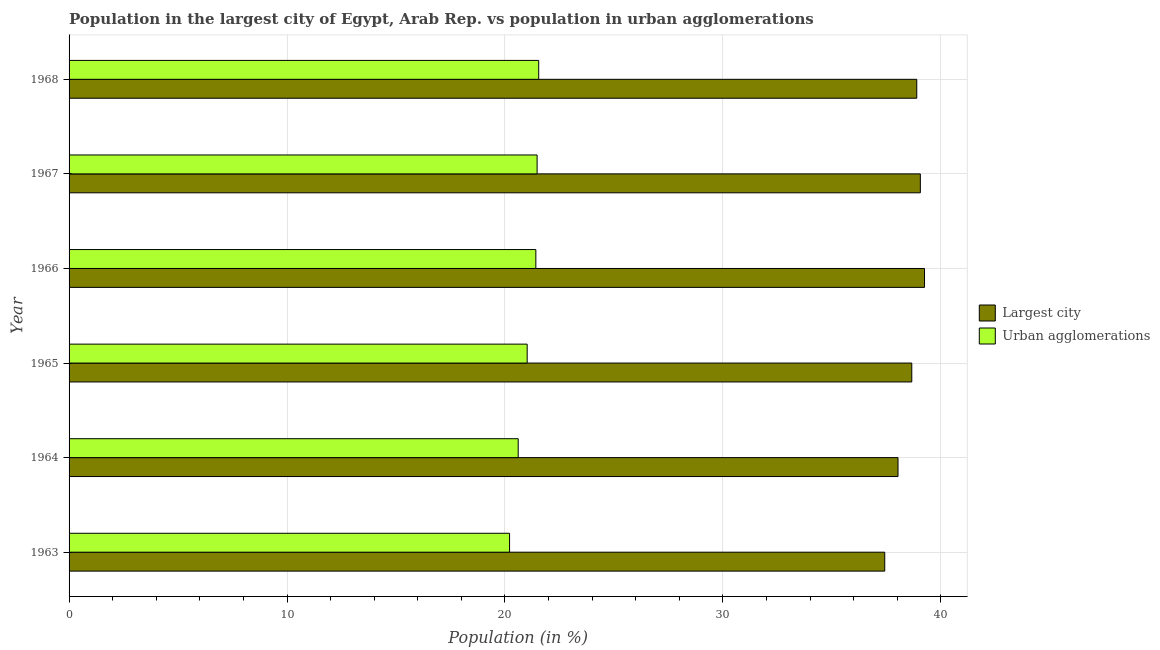How many groups of bars are there?
Your answer should be compact. 6. How many bars are there on the 4th tick from the bottom?
Offer a very short reply. 2. What is the label of the 3rd group of bars from the top?
Keep it short and to the point. 1966. What is the population in urban agglomerations in 1963?
Provide a short and direct response. 20.21. Across all years, what is the maximum population in urban agglomerations?
Your response must be concise. 21.55. Across all years, what is the minimum population in urban agglomerations?
Ensure brevity in your answer.  20.21. In which year was the population in the largest city maximum?
Your answer should be very brief. 1966. What is the total population in the largest city in the graph?
Make the answer very short. 231.35. What is the difference between the population in the largest city in 1964 and that in 1967?
Offer a terse response. -1.02. What is the difference between the population in urban agglomerations in 1966 and the population in the largest city in 1967?
Give a very brief answer. -17.64. What is the average population in the largest city per year?
Your response must be concise. 38.56. In the year 1966, what is the difference between the population in urban agglomerations and population in the largest city?
Make the answer very short. -17.84. In how many years, is the population in the largest city greater than 22 %?
Your answer should be compact. 6. What is the ratio of the population in urban agglomerations in 1967 to that in 1968?
Your answer should be very brief. 1. Is the population in the largest city in 1964 less than that in 1968?
Give a very brief answer. Yes. What is the difference between the highest and the second highest population in the largest city?
Make the answer very short. 0.19. What is the difference between the highest and the lowest population in urban agglomerations?
Give a very brief answer. 1.34. Is the sum of the population in urban agglomerations in 1963 and 1965 greater than the maximum population in the largest city across all years?
Provide a succinct answer. Yes. What does the 2nd bar from the top in 1968 represents?
Make the answer very short. Largest city. What does the 2nd bar from the bottom in 1965 represents?
Offer a terse response. Urban agglomerations. How many bars are there?
Offer a very short reply. 12. Are all the bars in the graph horizontal?
Provide a short and direct response. Yes. How many years are there in the graph?
Your answer should be very brief. 6. Are the values on the major ticks of X-axis written in scientific E-notation?
Ensure brevity in your answer.  No. Does the graph contain any zero values?
Keep it short and to the point. No. How are the legend labels stacked?
Give a very brief answer. Vertical. What is the title of the graph?
Make the answer very short. Population in the largest city of Egypt, Arab Rep. vs population in urban agglomerations. Does "Measles" appear as one of the legend labels in the graph?
Your answer should be compact. No. What is the label or title of the X-axis?
Offer a terse response. Population (in %). What is the label or title of the Y-axis?
Keep it short and to the point. Year. What is the Population (in %) of Largest city in 1963?
Offer a terse response. 37.43. What is the Population (in %) of Urban agglomerations in 1963?
Your response must be concise. 20.21. What is the Population (in %) in Largest city in 1964?
Your answer should be very brief. 38.04. What is the Population (in %) of Urban agglomerations in 1964?
Give a very brief answer. 20.61. What is the Population (in %) in Largest city in 1965?
Provide a short and direct response. 38.67. What is the Population (in %) of Urban agglomerations in 1965?
Provide a succinct answer. 21.02. What is the Population (in %) of Largest city in 1966?
Keep it short and to the point. 39.25. What is the Population (in %) in Urban agglomerations in 1966?
Keep it short and to the point. 21.42. What is the Population (in %) in Largest city in 1967?
Your answer should be very brief. 39.06. What is the Population (in %) in Urban agglomerations in 1967?
Your answer should be very brief. 21.48. What is the Population (in %) of Largest city in 1968?
Keep it short and to the point. 38.9. What is the Population (in %) in Urban agglomerations in 1968?
Ensure brevity in your answer.  21.55. Across all years, what is the maximum Population (in %) in Largest city?
Keep it short and to the point. 39.25. Across all years, what is the maximum Population (in %) in Urban agglomerations?
Provide a short and direct response. 21.55. Across all years, what is the minimum Population (in %) of Largest city?
Provide a short and direct response. 37.43. Across all years, what is the minimum Population (in %) in Urban agglomerations?
Your answer should be very brief. 20.21. What is the total Population (in %) of Largest city in the graph?
Keep it short and to the point. 231.35. What is the total Population (in %) in Urban agglomerations in the graph?
Keep it short and to the point. 126.29. What is the difference between the Population (in %) in Largest city in 1963 and that in 1964?
Give a very brief answer. -0.61. What is the difference between the Population (in %) of Urban agglomerations in 1963 and that in 1964?
Your response must be concise. -0.4. What is the difference between the Population (in %) in Largest city in 1963 and that in 1965?
Provide a succinct answer. -1.24. What is the difference between the Population (in %) of Urban agglomerations in 1963 and that in 1965?
Offer a terse response. -0.81. What is the difference between the Population (in %) of Largest city in 1963 and that in 1966?
Offer a terse response. -1.83. What is the difference between the Population (in %) in Urban agglomerations in 1963 and that in 1966?
Provide a short and direct response. -1.21. What is the difference between the Population (in %) in Largest city in 1963 and that in 1967?
Your response must be concise. -1.63. What is the difference between the Population (in %) in Urban agglomerations in 1963 and that in 1967?
Give a very brief answer. -1.26. What is the difference between the Population (in %) of Largest city in 1963 and that in 1968?
Make the answer very short. -1.47. What is the difference between the Population (in %) of Urban agglomerations in 1963 and that in 1968?
Provide a short and direct response. -1.34. What is the difference between the Population (in %) of Largest city in 1964 and that in 1965?
Ensure brevity in your answer.  -0.63. What is the difference between the Population (in %) of Urban agglomerations in 1964 and that in 1965?
Give a very brief answer. -0.41. What is the difference between the Population (in %) of Largest city in 1964 and that in 1966?
Keep it short and to the point. -1.22. What is the difference between the Population (in %) of Urban agglomerations in 1964 and that in 1966?
Ensure brevity in your answer.  -0.81. What is the difference between the Population (in %) of Largest city in 1964 and that in 1967?
Provide a succinct answer. -1.02. What is the difference between the Population (in %) of Urban agglomerations in 1964 and that in 1967?
Your answer should be compact. -0.87. What is the difference between the Population (in %) of Largest city in 1964 and that in 1968?
Make the answer very short. -0.86. What is the difference between the Population (in %) in Urban agglomerations in 1964 and that in 1968?
Keep it short and to the point. -0.94. What is the difference between the Population (in %) in Largest city in 1965 and that in 1966?
Ensure brevity in your answer.  -0.58. What is the difference between the Population (in %) of Urban agglomerations in 1965 and that in 1966?
Give a very brief answer. -0.4. What is the difference between the Population (in %) of Largest city in 1965 and that in 1967?
Ensure brevity in your answer.  -0.39. What is the difference between the Population (in %) of Urban agglomerations in 1965 and that in 1967?
Offer a very short reply. -0.46. What is the difference between the Population (in %) in Largest city in 1965 and that in 1968?
Keep it short and to the point. -0.23. What is the difference between the Population (in %) of Urban agglomerations in 1965 and that in 1968?
Provide a short and direct response. -0.53. What is the difference between the Population (in %) in Largest city in 1966 and that in 1967?
Ensure brevity in your answer.  0.19. What is the difference between the Population (in %) in Urban agglomerations in 1966 and that in 1967?
Provide a short and direct response. -0.06. What is the difference between the Population (in %) in Largest city in 1966 and that in 1968?
Keep it short and to the point. 0.36. What is the difference between the Population (in %) in Urban agglomerations in 1966 and that in 1968?
Provide a short and direct response. -0.13. What is the difference between the Population (in %) of Largest city in 1967 and that in 1968?
Provide a short and direct response. 0.16. What is the difference between the Population (in %) of Urban agglomerations in 1967 and that in 1968?
Your response must be concise. -0.07. What is the difference between the Population (in %) of Largest city in 1963 and the Population (in %) of Urban agglomerations in 1964?
Provide a succinct answer. 16.82. What is the difference between the Population (in %) in Largest city in 1963 and the Population (in %) in Urban agglomerations in 1965?
Provide a succinct answer. 16.41. What is the difference between the Population (in %) in Largest city in 1963 and the Population (in %) in Urban agglomerations in 1966?
Make the answer very short. 16.01. What is the difference between the Population (in %) of Largest city in 1963 and the Population (in %) of Urban agglomerations in 1967?
Your response must be concise. 15.95. What is the difference between the Population (in %) of Largest city in 1963 and the Population (in %) of Urban agglomerations in 1968?
Offer a terse response. 15.88. What is the difference between the Population (in %) of Largest city in 1964 and the Population (in %) of Urban agglomerations in 1965?
Your answer should be very brief. 17.02. What is the difference between the Population (in %) of Largest city in 1964 and the Population (in %) of Urban agglomerations in 1966?
Keep it short and to the point. 16.62. What is the difference between the Population (in %) in Largest city in 1964 and the Population (in %) in Urban agglomerations in 1967?
Give a very brief answer. 16.56. What is the difference between the Population (in %) of Largest city in 1964 and the Population (in %) of Urban agglomerations in 1968?
Ensure brevity in your answer.  16.49. What is the difference between the Population (in %) of Largest city in 1965 and the Population (in %) of Urban agglomerations in 1966?
Give a very brief answer. 17.25. What is the difference between the Population (in %) of Largest city in 1965 and the Population (in %) of Urban agglomerations in 1967?
Your answer should be compact. 17.19. What is the difference between the Population (in %) of Largest city in 1965 and the Population (in %) of Urban agglomerations in 1968?
Offer a terse response. 17.12. What is the difference between the Population (in %) of Largest city in 1966 and the Population (in %) of Urban agglomerations in 1967?
Your response must be concise. 17.78. What is the difference between the Population (in %) in Largest city in 1966 and the Population (in %) in Urban agglomerations in 1968?
Your answer should be very brief. 17.7. What is the difference between the Population (in %) of Largest city in 1967 and the Population (in %) of Urban agglomerations in 1968?
Offer a terse response. 17.51. What is the average Population (in %) of Largest city per year?
Give a very brief answer. 38.56. What is the average Population (in %) of Urban agglomerations per year?
Give a very brief answer. 21.05. In the year 1963, what is the difference between the Population (in %) in Largest city and Population (in %) in Urban agglomerations?
Provide a succinct answer. 17.22. In the year 1964, what is the difference between the Population (in %) of Largest city and Population (in %) of Urban agglomerations?
Make the answer very short. 17.43. In the year 1965, what is the difference between the Population (in %) in Largest city and Population (in %) in Urban agglomerations?
Give a very brief answer. 17.65. In the year 1966, what is the difference between the Population (in %) of Largest city and Population (in %) of Urban agglomerations?
Your answer should be very brief. 17.84. In the year 1967, what is the difference between the Population (in %) of Largest city and Population (in %) of Urban agglomerations?
Give a very brief answer. 17.59. In the year 1968, what is the difference between the Population (in %) of Largest city and Population (in %) of Urban agglomerations?
Offer a terse response. 17.35. What is the ratio of the Population (in %) in Urban agglomerations in 1963 to that in 1964?
Ensure brevity in your answer.  0.98. What is the ratio of the Population (in %) in Largest city in 1963 to that in 1965?
Ensure brevity in your answer.  0.97. What is the ratio of the Population (in %) in Urban agglomerations in 1963 to that in 1965?
Provide a short and direct response. 0.96. What is the ratio of the Population (in %) in Largest city in 1963 to that in 1966?
Your answer should be compact. 0.95. What is the ratio of the Population (in %) of Urban agglomerations in 1963 to that in 1966?
Provide a short and direct response. 0.94. What is the ratio of the Population (in %) in Largest city in 1963 to that in 1967?
Offer a terse response. 0.96. What is the ratio of the Population (in %) of Urban agglomerations in 1963 to that in 1967?
Make the answer very short. 0.94. What is the ratio of the Population (in %) in Largest city in 1963 to that in 1968?
Offer a terse response. 0.96. What is the ratio of the Population (in %) in Urban agglomerations in 1963 to that in 1968?
Keep it short and to the point. 0.94. What is the ratio of the Population (in %) of Largest city in 1964 to that in 1965?
Provide a succinct answer. 0.98. What is the ratio of the Population (in %) in Urban agglomerations in 1964 to that in 1965?
Offer a very short reply. 0.98. What is the ratio of the Population (in %) of Urban agglomerations in 1964 to that in 1966?
Keep it short and to the point. 0.96. What is the ratio of the Population (in %) in Largest city in 1964 to that in 1967?
Your response must be concise. 0.97. What is the ratio of the Population (in %) of Urban agglomerations in 1964 to that in 1967?
Offer a very short reply. 0.96. What is the ratio of the Population (in %) of Largest city in 1964 to that in 1968?
Provide a short and direct response. 0.98. What is the ratio of the Population (in %) of Urban agglomerations in 1964 to that in 1968?
Ensure brevity in your answer.  0.96. What is the ratio of the Population (in %) of Largest city in 1965 to that in 1966?
Ensure brevity in your answer.  0.99. What is the ratio of the Population (in %) in Urban agglomerations in 1965 to that in 1966?
Provide a short and direct response. 0.98. What is the ratio of the Population (in %) of Urban agglomerations in 1965 to that in 1967?
Offer a very short reply. 0.98. What is the ratio of the Population (in %) of Urban agglomerations in 1965 to that in 1968?
Offer a very short reply. 0.98. What is the ratio of the Population (in %) in Urban agglomerations in 1966 to that in 1967?
Your response must be concise. 1. What is the ratio of the Population (in %) of Largest city in 1966 to that in 1968?
Offer a terse response. 1.01. What is the ratio of the Population (in %) of Urban agglomerations in 1966 to that in 1968?
Provide a short and direct response. 0.99. What is the ratio of the Population (in %) of Largest city in 1967 to that in 1968?
Make the answer very short. 1. What is the ratio of the Population (in %) in Urban agglomerations in 1967 to that in 1968?
Keep it short and to the point. 1. What is the difference between the highest and the second highest Population (in %) of Largest city?
Keep it short and to the point. 0.19. What is the difference between the highest and the second highest Population (in %) in Urban agglomerations?
Keep it short and to the point. 0.07. What is the difference between the highest and the lowest Population (in %) of Largest city?
Your response must be concise. 1.83. What is the difference between the highest and the lowest Population (in %) of Urban agglomerations?
Provide a short and direct response. 1.34. 